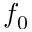Convert formula to latex. <formula><loc_0><loc_0><loc_500><loc_500>f _ { 0 }</formula> 